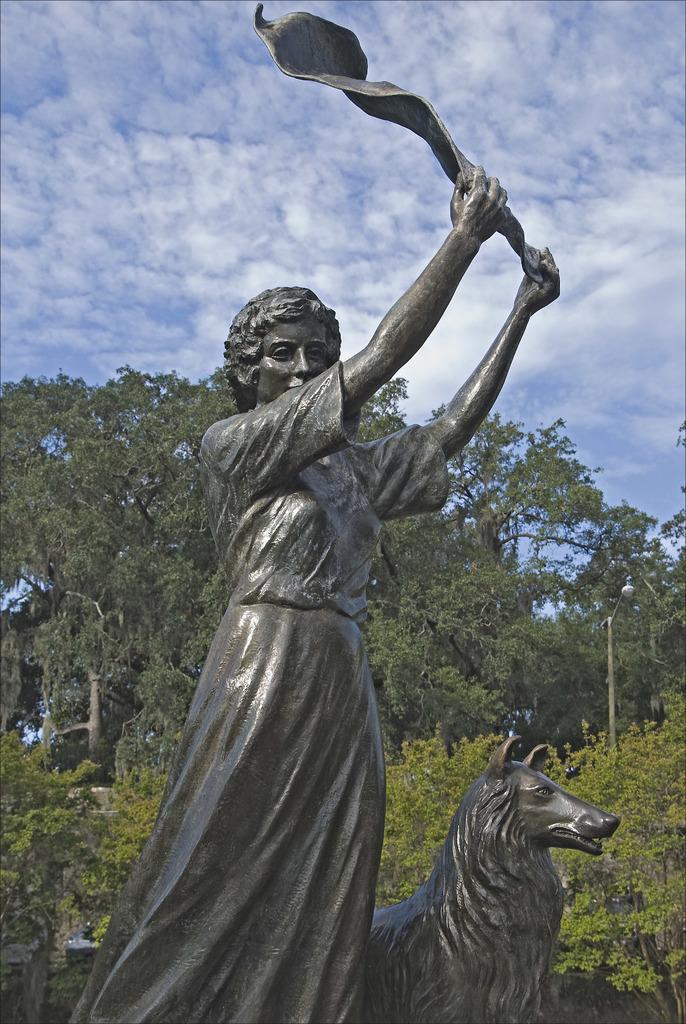Describe this image in one or two sentences. In this image we can see statues, bushes, trees, street poles, street lights and sky with clouds. 